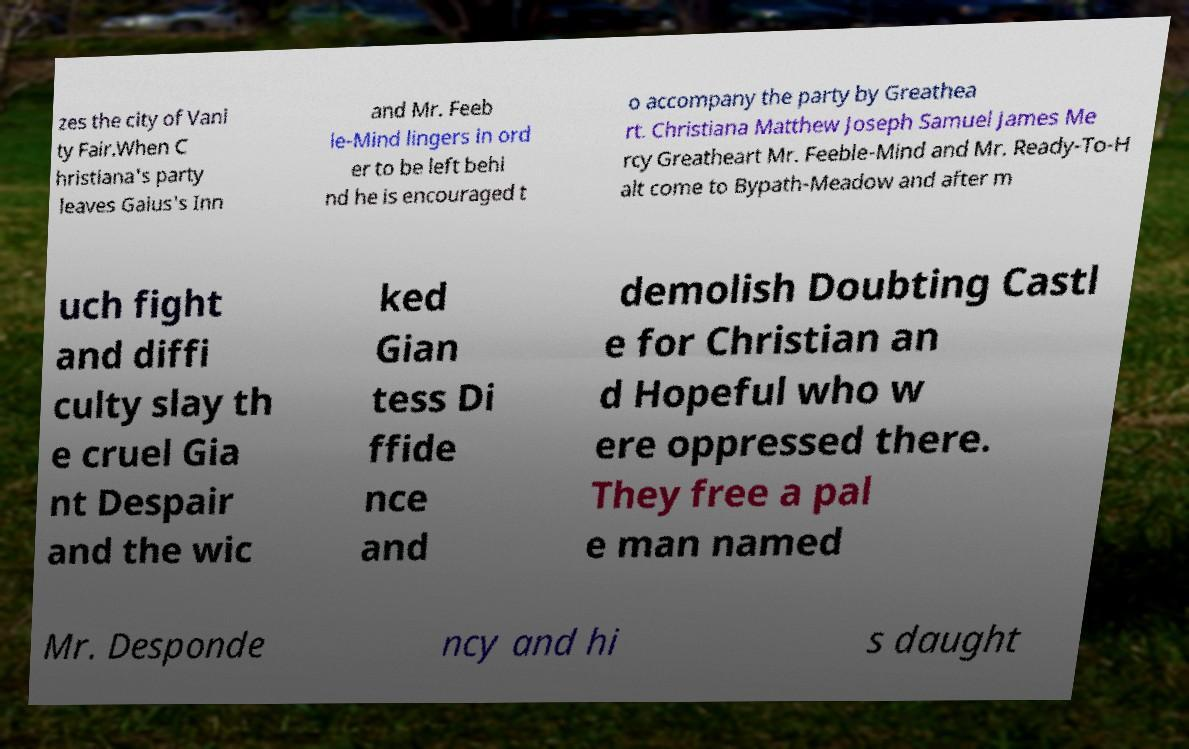Please read and relay the text visible in this image. What does it say? zes the city of Vani ty Fair.When C hristiana's party leaves Gaius's Inn and Mr. Feeb le-Mind lingers in ord er to be left behi nd he is encouraged t o accompany the party by Greathea rt. Christiana Matthew Joseph Samuel James Me rcy Greatheart Mr. Feeble-Mind and Mr. Ready-To-H alt come to Bypath-Meadow and after m uch fight and diffi culty slay th e cruel Gia nt Despair and the wic ked Gian tess Di ffide nce and demolish Doubting Castl e for Christian an d Hopeful who w ere oppressed there. They free a pal e man named Mr. Desponde ncy and hi s daught 